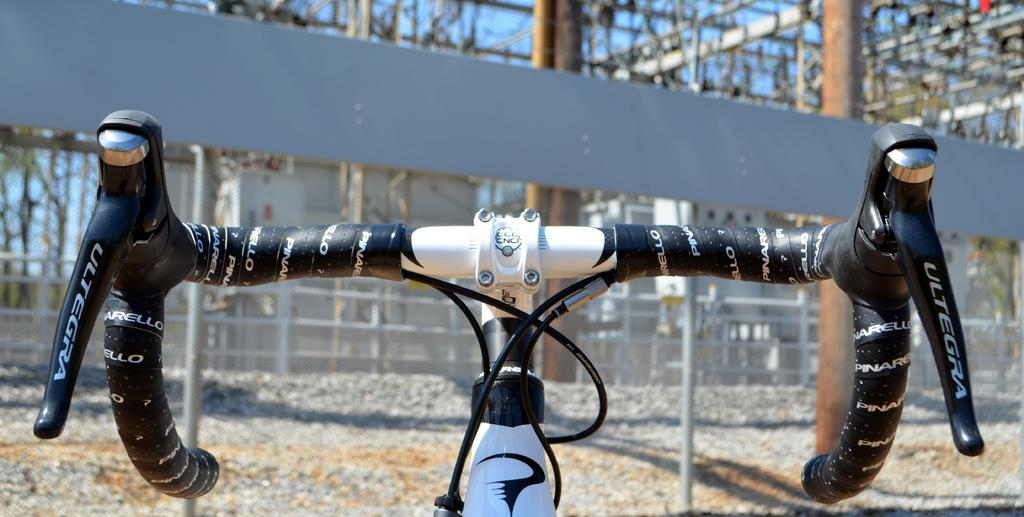What is the main object in the image? There is a bicycle handle in the image. What type of structure is present in the image? There is a fencing grill in the image. What material are the frames made of in the image? There are iron frames in the image. Who is the writer in the image? There is no writer present in the image. What type of bells can be heard in the image? There are no bells present in the image, so it's not possible to determine what they might sound like. 